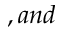Convert formula to latex. <formula><loc_0><loc_0><loc_500><loc_500>, a n d</formula> 